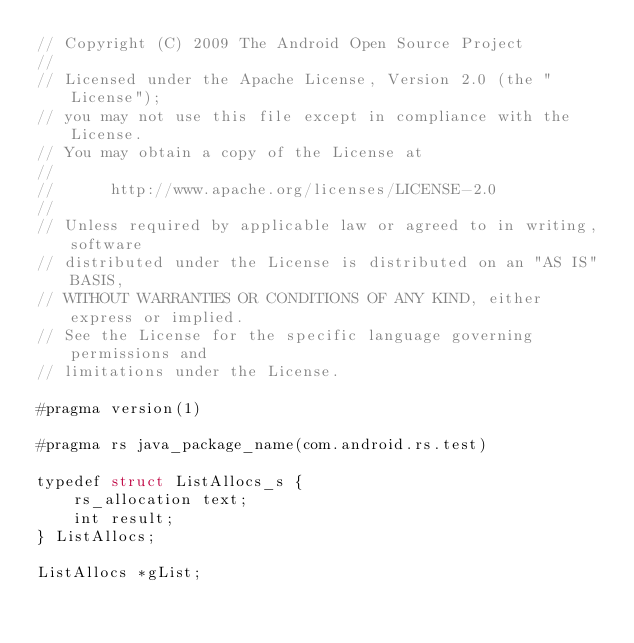Convert code to text. <code><loc_0><loc_0><loc_500><loc_500><_Rust_>// Copyright (C) 2009 The Android Open Source Project
//
// Licensed under the Apache License, Version 2.0 (the "License");
// you may not use this file except in compliance with the License.
// You may obtain a copy of the License at
//
//      http://www.apache.org/licenses/LICENSE-2.0
//
// Unless required by applicable law or agreed to in writing, software
// distributed under the License is distributed on an "AS IS" BASIS,
// WITHOUT WARRANTIES OR CONDITIONS OF ANY KIND, either express or implied.
// See the License for the specific language governing permissions and
// limitations under the License.

#pragma version(1)

#pragma rs java_package_name(com.android.rs.test)

typedef struct ListAllocs_s {
    rs_allocation text;
    int result;
} ListAllocs;

ListAllocs *gList;

</code> 